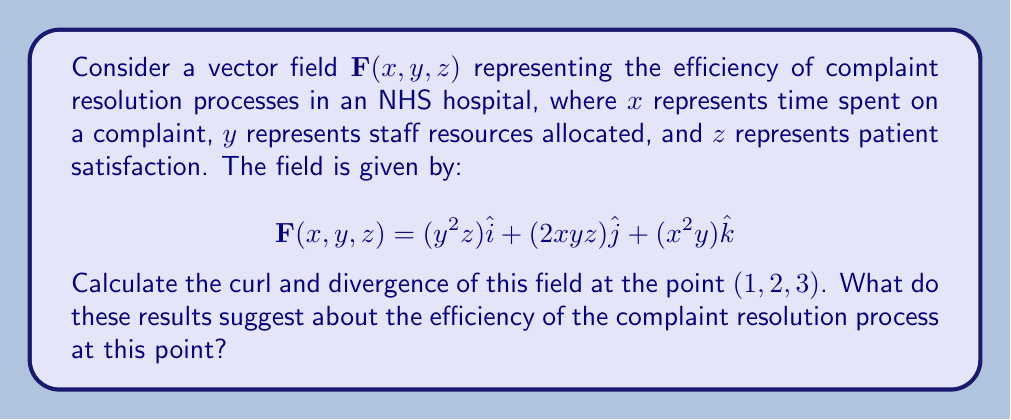Help me with this question. To solve this problem, we need to calculate the curl and divergence of the given vector field at the specified point. Let's break it down step by step:

1. Curl calculation:
The curl of a vector field $\mathbf{F}(x, y, z) = P\hat{i} + Q\hat{j} + R\hat{k}$ is given by:

$$\text{curl }\mathbf{F} = \nabla \times \mathbf{F} = \left(\frac{\partial R}{\partial y} - \frac{\partial Q}{\partial z}\right)\hat{i} + \left(\frac{\partial P}{\partial z} - \frac{\partial R}{\partial x}\right)\hat{j} + \left(\frac{\partial Q}{\partial x} - \frac{\partial P}{\partial y}\right)\hat{k}$$

For our vector field:
$P = y^2z$, $Q = 2xyz$, $R = x^2y$

Calculating the partial derivatives:
$\frac{\partial R}{\partial y} = x^2$
$\frac{\partial Q}{\partial z} = 2xy$
$\frac{\partial P}{\partial z} = y^2$
$\frac{\partial R}{\partial x} = 2xy$
$\frac{\partial Q}{\partial x} = 2yz$
$\frac{\partial P}{\partial y} = 2yz$

Now, we can compute the curl:
$$\text{curl }\mathbf{F} = (x^2 - 2xy)\hat{i} + (y^2 - 2xy)\hat{j} + (2yz - 2yz)\hat{k}$$

At the point (1, 2, 3):
$$\text{curl }\mathbf{F}(1, 2, 3) = (1 - 4)\hat{i} + (4 - 4)\hat{j} + (12 - 12)\hat{k} = -3\hat{i}$$

2. Divergence calculation:
The divergence of a vector field $\mathbf{F}(x, y, z) = P\hat{i} + Q\hat{j} + R\hat{k}$ is given by:

$$\text{div }\mathbf{F} = \nabla \cdot \mathbf{F} = \frac{\partial P}{\partial x} + \frac{\partial Q}{\partial y} + \frac{\partial R}{\partial z}$$

Calculating the partial derivatives:
$\frac{\partial P}{\partial x} = 0$
$\frac{\partial Q}{\partial y} = 2xz$
$\frac{\partial R}{\partial z} = 0$

Now, we can compute the divergence:
$$\text{div }\mathbf{F} = 0 + 2xz + 0 = 2xz$$

At the point (1, 2, 3):
$$\text{div }\mathbf{F}(1, 2, 3) = 2(1)(3) = 6$$

Interpretation:
The non-zero curl (-3î) suggests that there is some rotational or circular component in the efficiency of the complaint resolution process. This might indicate that resources are not being used in the most direct manner to resolve complaints.

The positive divergence (6) indicates that there is an overall outward flow or expansion in the efficiency field at this point. This could suggest that the process is becoming more efficient or that resources are being utilized effectively.

However, the magnitude of the divergence is larger than the magnitude of the curl, which might imply that the overall efficiency is increasing more significantly than any circular inefficiencies in the process.
Answer: Curl: $\text{curl }\mathbf{F}(1, 2, 3) = -3\hat{i}$
Divergence: $\text{div }\mathbf{F}(1, 2, 3) = 6$

These results suggest that at the point (1, 2, 3), the complaint resolution process has some rotational inefficiency (indicated by the non-zero curl) but is overall expanding in efficiency (indicated by the positive divergence). The larger magnitude of the divergence compared to the curl suggests that the process is generally becoming more efficient despite some circular resource usage. 